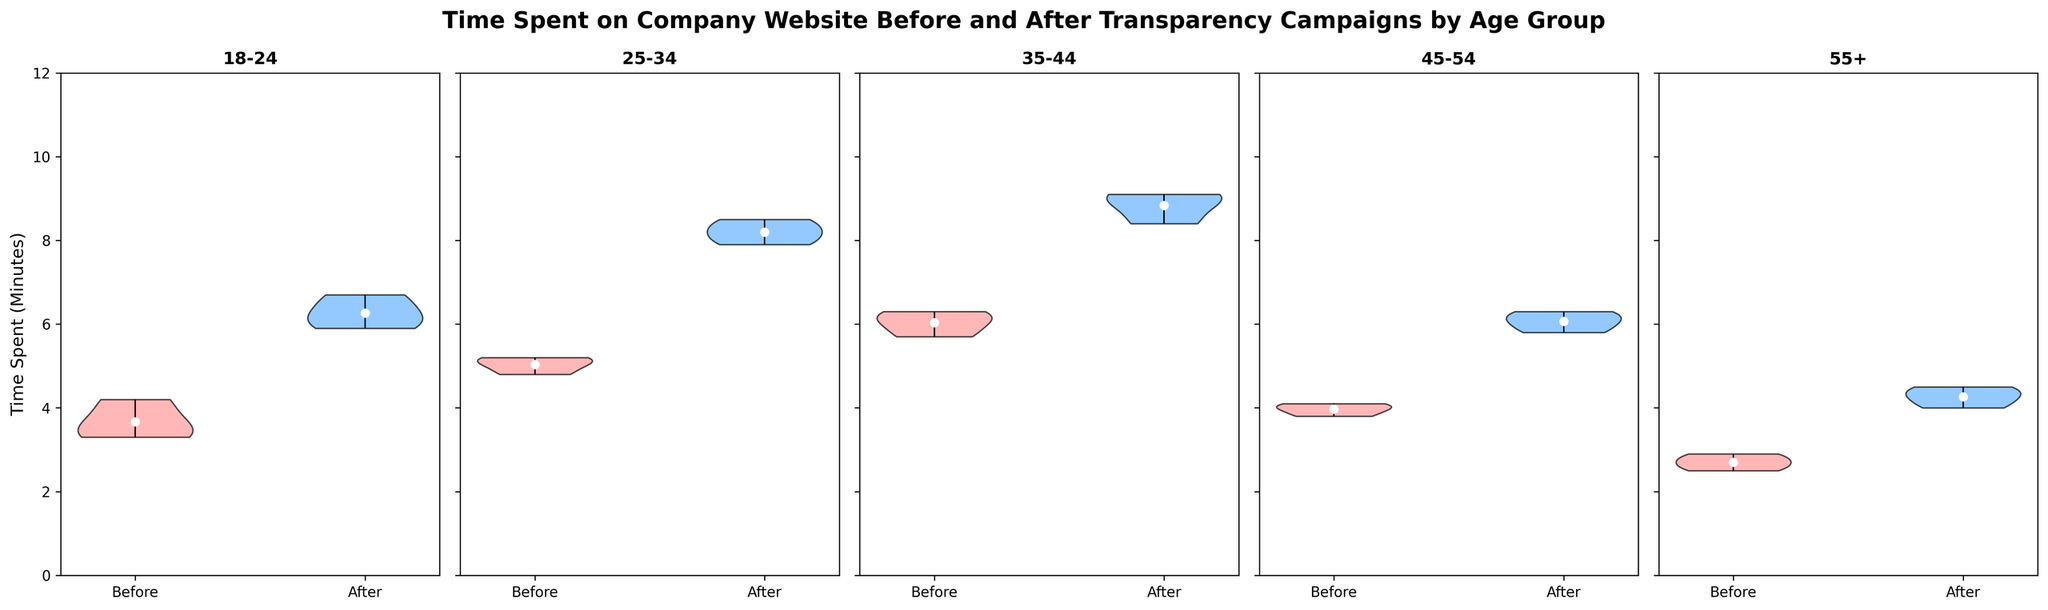What is the title of the figure? The title text is located at the top of the figure and is a straightforward visual element to identify.
Answer: Time Spent on Company Website Before and After Transparency Campaigns by Age Group How many age groups are displayed in the figure? The age groups are titles above each subplot of the violin charts. There are five distinct titles.
Answer: 5 Which age group shows the highest increase in the average time spent on the website after the transparency campaign? To determine this, compare the white dots (representing the average) in the "Before" and "After" periods for each age group. The largest vertical distance between these dots indicates the highest increase. The 35-44 age group shows the most significant increase.
Answer: 35-44 What is the average time spent on the website after the transparency campaign for the 18-24 age group? Locate the white dot in the "After" violin plot for the 18-24 age group.
Answer: 6.2 minutes Which period (Before or After) shows a wider spread in time spent for the 55+ age group? Wider spread can be identified by looking at the size of the violin plots. For the 55+ age group, the "After" period shows a broader spread.
Answer: After What are the colors used to represent the 'Before' and 'After' periods in each violin plot? The colors fill the violins and are described in the legend or can be directly seen. The 'Before' period is red and the 'After' period is blue.
Answer: Red for Before and Blue for After Is the average time spent on the website after the campaign for the 25-34 age group higher or lower than that for the 45-54 age group? Compare the locations of the white dots representing the averages in the "After" period for both age groups. The 25-34 age group's average time is higher.
Answer: Higher Which age group had the smallest average increase in time spent on the website after the campaign? Evaluate each group by comparing the vertical distance of the white dots from "Before" to "After" periods. The smallest increase is seen in the 55+ age group.
Answer: 55+ What is the approximate median value of time spent on the website after the transparency campaign for the 35-44 age group? The median value would be the central tendency in the "After" plot for the 35-44 age group violin chart. The band around 9.0 is approximately the median.
Answer: 9.0 minutes 